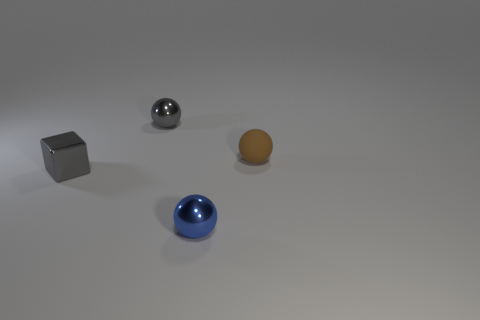Subtract all small metallic spheres. How many spheres are left? 1 Add 1 gray cubes. How many objects exist? 5 Subtract all balls. How many objects are left? 1 Subtract all brown spheres. How many spheres are left? 2 Subtract all yellow balls. How many cyan cubes are left? 0 Subtract all small green metal balls. Subtract all small rubber objects. How many objects are left? 3 Add 1 blue shiny balls. How many blue shiny balls are left? 2 Add 1 big yellow matte cylinders. How many big yellow matte cylinders exist? 1 Subtract 0 cyan cubes. How many objects are left? 4 Subtract 1 cubes. How many cubes are left? 0 